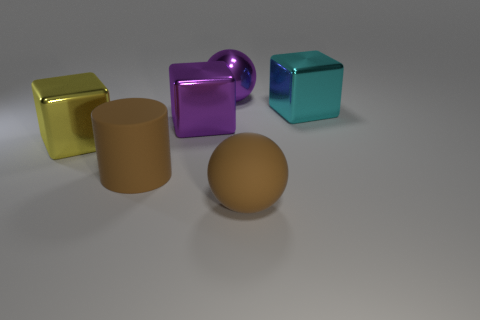Add 1 purple shiny cylinders. How many objects exist? 7 Subtract all balls. How many objects are left? 4 Add 4 purple things. How many purple things exist? 6 Subtract 0 yellow balls. How many objects are left? 6 Subtract all brown metallic cylinders. Subtract all metallic balls. How many objects are left? 5 Add 4 rubber things. How many rubber things are left? 6 